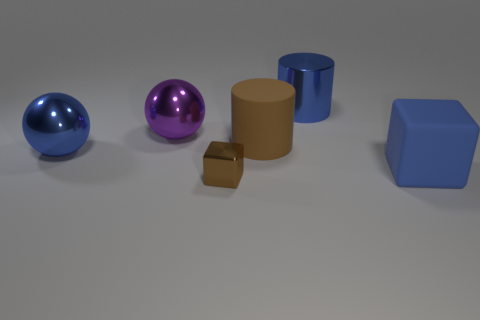Subtract all green blocks. Subtract all brown spheres. How many blocks are left? 2 Add 1 spheres. How many objects exist? 7 Subtract all cylinders. How many objects are left? 4 Add 3 large purple metal things. How many large purple metal things exist? 4 Subtract 0 red cubes. How many objects are left? 6 Subtract all small shiny blocks. Subtract all tiny purple rubber blocks. How many objects are left? 5 Add 6 blue metallic objects. How many blue metallic objects are left? 8 